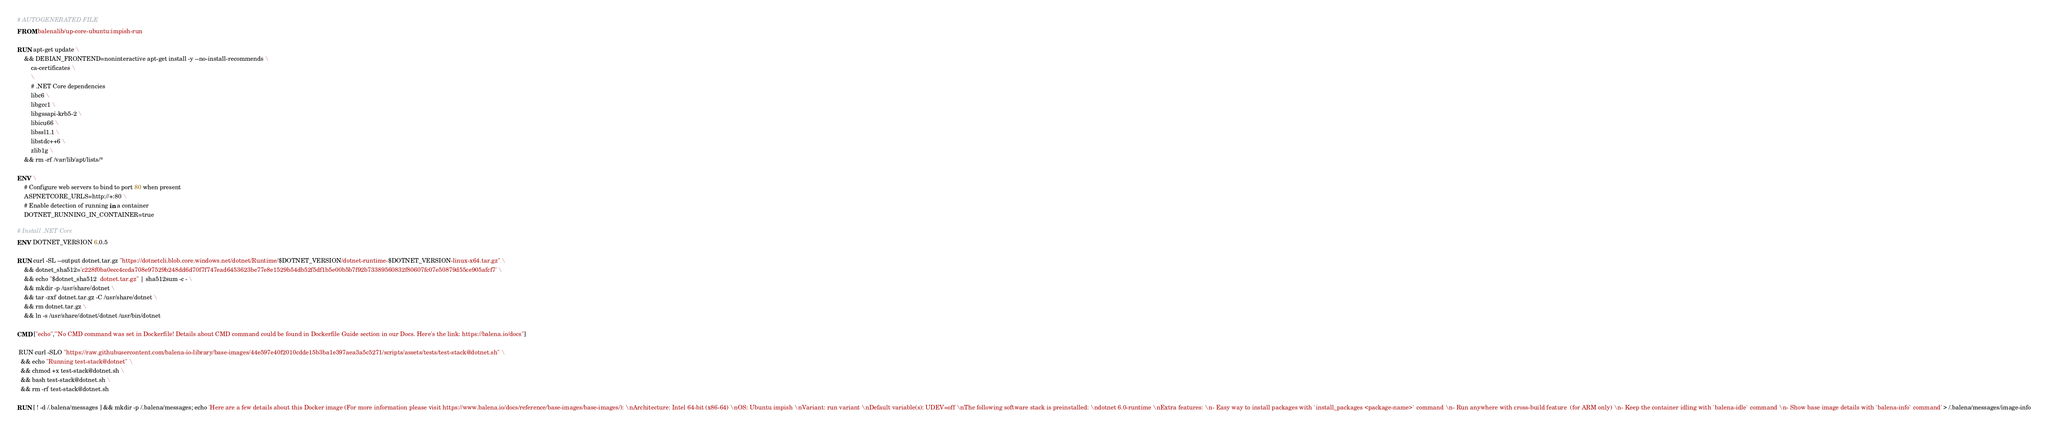Convert code to text. <code><loc_0><loc_0><loc_500><loc_500><_Dockerfile_># AUTOGENERATED FILE
FROM balenalib/up-core-ubuntu:impish-run

RUN apt-get update \
    && DEBIAN_FRONTEND=noninteractive apt-get install -y --no-install-recommends \
        ca-certificates \
        \
        # .NET Core dependencies
        libc6 \
        libgcc1 \
        libgssapi-krb5-2 \
        libicu66 \
        libssl1.1 \
        libstdc++6 \
        zlib1g \
    && rm -rf /var/lib/apt/lists/*

ENV \
    # Configure web servers to bind to port 80 when present
    ASPNETCORE_URLS=http://+:80 \
    # Enable detection of running in a container
    DOTNET_RUNNING_IN_CONTAINER=true

# Install .NET Core
ENV DOTNET_VERSION 6.0.5

RUN curl -SL --output dotnet.tar.gz "https://dotnetcli.blob.core.windows.net/dotnet/Runtime/$DOTNET_VERSION/dotnet-runtime-$DOTNET_VERSION-linux-x64.tar.gz" \
    && dotnet_sha512='c228f0ba0ecc4ccda708e97529b248dd6d70f7f747ead6453623be77e8e1529b54db52f5df1b5e00b5b7f92b73389560832f80607fc07e50879d55ce905afcf7' \
    && echo "$dotnet_sha512  dotnet.tar.gz" | sha512sum -c - \
    && mkdir -p /usr/share/dotnet \
    && tar -zxf dotnet.tar.gz -C /usr/share/dotnet \
    && rm dotnet.tar.gz \
    && ln -s /usr/share/dotnet/dotnet /usr/bin/dotnet

CMD ["echo","'No CMD command was set in Dockerfile! Details about CMD command could be found in Dockerfile Guide section in our Docs. Here's the link: https://balena.io/docs"]

 RUN curl -SLO "https://raw.githubusercontent.com/balena-io-library/base-images/44e597e40f2010cdde15b3ba1e397aea3a5c5271/scripts/assets/tests/test-stack@dotnet.sh" \
  && echo "Running test-stack@dotnet" \
  && chmod +x test-stack@dotnet.sh \
  && bash test-stack@dotnet.sh \
  && rm -rf test-stack@dotnet.sh 

RUN [ ! -d /.balena/messages ] && mkdir -p /.balena/messages; echo 'Here are a few details about this Docker image (For more information please visit https://www.balena.io/docs/reference/base-images/base-images/): \nArchitecture: Intel 64-bit (x86-64) \nOS: Ubuntu impish \nVariant: run variant \nDefault variable(s): UDEV=off \nThe following software stack is preinstalled: \ndotnet 6.0-runtime \nExtra features: \n- Easy way to install packages with `install_packages <package-name>` command \n- Run anywhere with cross-build feature  (for ARM only) \n- Keep the container idling with `balena-idle` command \n- Show base image details with `balena-info` command' > /.balena/messages/image-info</code> 